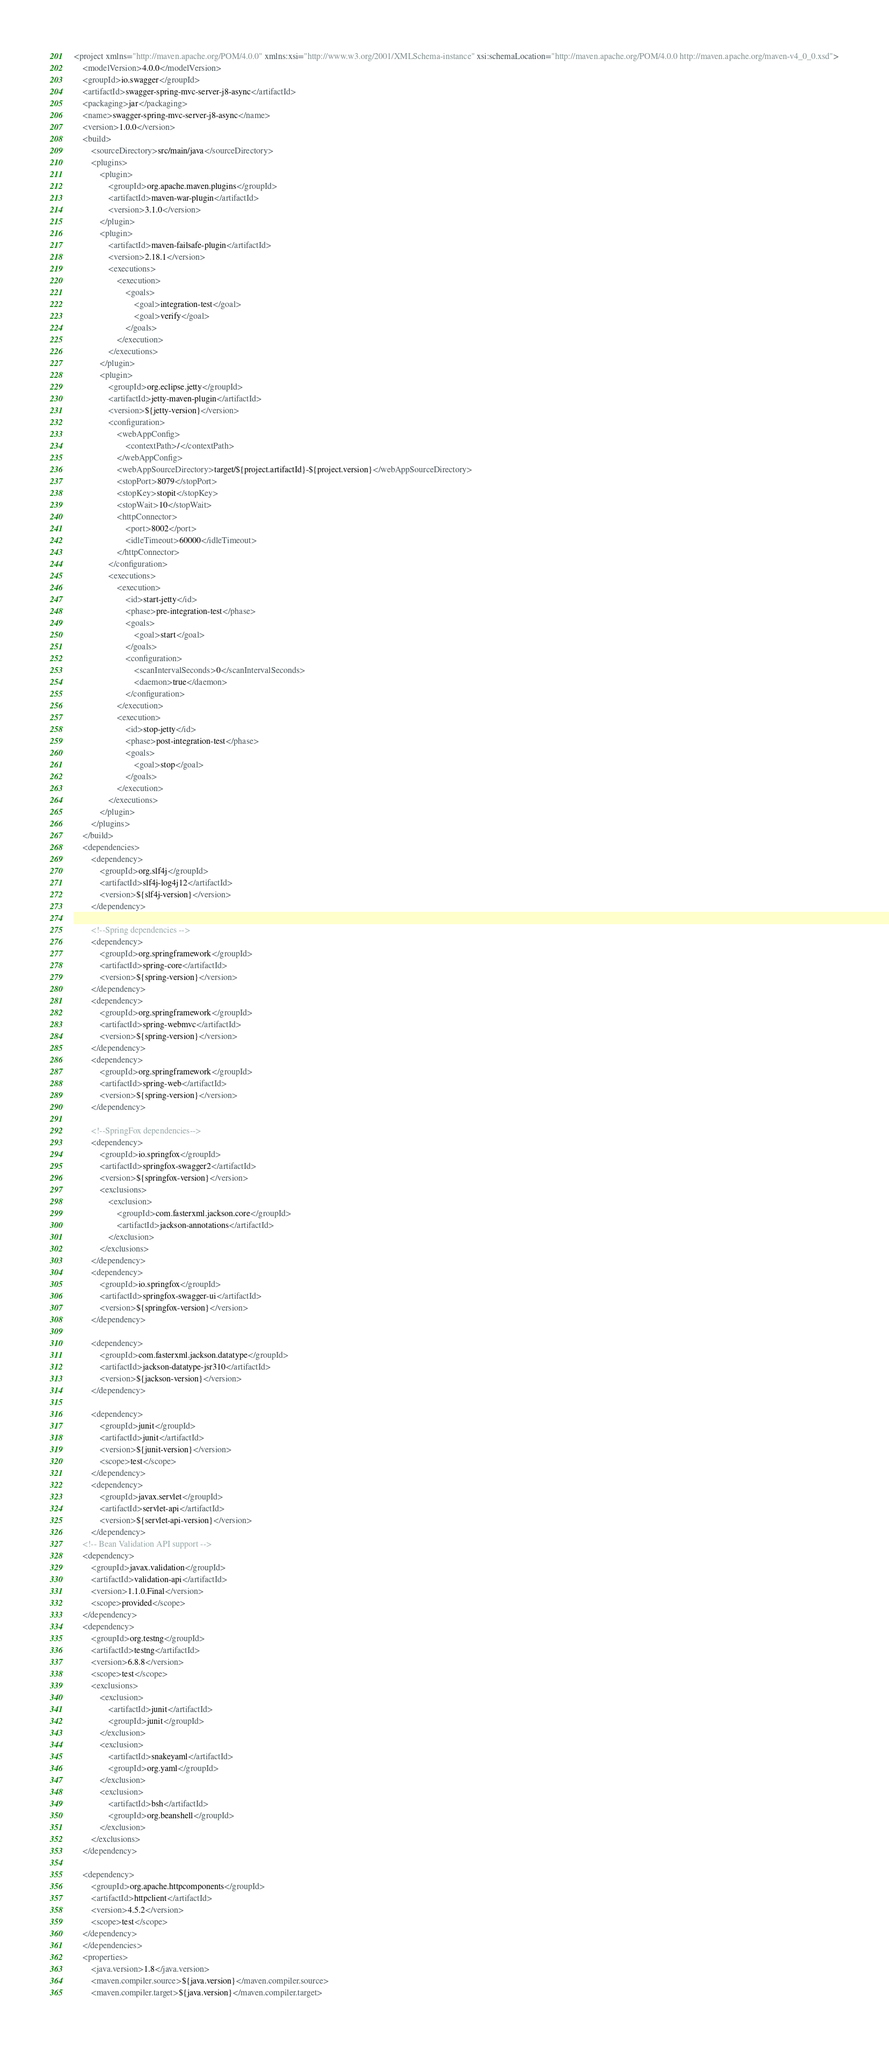<code> <loc_0><loc_0><loc_500><loc_500><_XML_><project xmlns="http://maven.apache.org/POM/4.0.0" xmlns:xsi="http://www.w3.org/2001/XMLSchema-instance" xsi:schemaLocation="http://maven.apache.org/POM/4.0.0 http://maven.apache.org/maven-v4_0_0.xsd">
    <modelVersion>4.0.0</modelVersion>
    <groupId>io.swagger</groupId>
    <artifactId>swagger-spring-mvc-server-j8-async</artifactId>
    <packaging>jar</packaging>
    <name>swagger-spring-mvc-server-j8-async</name>
    <version>1.0.0</version>
    <build>
        <sourceDirectory>src/main/java</sourceDirectory>
        <plugins>
            <plugin>
                <groupId>org.apache.maven.plugins</groupId>
                <artifactId>maven-war-plugin</artifactId>
                <version>3.1.0</version>
            </plugin>
            <plugin>
                <artifactId>maven-failsafe-plugin</artifactId>
                <version>2.18.1</version>
                <executions>
                    <execution>
                        <goals>
                            <goal>integration-test</goal>
                            <goal>verify</goal>
                        </goals>
                    </execution>
                </executions>
            </plugin>
            <plugin>
                <groupId>org.eclipse.jetty</groupId>
                <artifactId>jetty-maven-plugin</artifactId>
                <version>${jetty-version}</version>
                <configuration>
                    <webAppConfig>
                        <contextPath>/</contextPath>
                    </webAppConfig>
                    <webAppSourceDirectory>target/${project.artifactId}-${project.version}</webAppSourceDirectory>
                    <stopPort>8079</stopPort>
                    <stopKey>stopit</stopKey>
                    <stopWait>10</stopWait>
                    <httpConnector>
                        <port>8002</port>
                        <idleTimeout>60000</idleTimeout>
                    </httpConnector>
                </configuration>
                <executions>
                    <execution>
                        <id>start-jetty</id>
                        <phase>pre-integration-test</phase>
                        <goals>
                            <goal>start</goal>
                        </goals>
                        <configuration>
                            <scanIntervalSeconds>0</scanIntervalSeconds>
                            <daemon>true</daemon>
                        </configuration>
                    </execution>
                    <execution>
                        <id>stop-jetty</id>
                        <phase>post-integration-test</phase>
                        <goals>
                            <goal>stop</goal>
                        </goals>
                    </execution>
                </executions>
            </plugin>
        </plugins>
    </build>
    <dependencies>
        <dependency>
            <groupId>org.slf4j</groupId>
            <artifactId>slf4j-log4j12</artifactId>
            <version>${slf4j-version}</version>
        </dependency>

        <!--Spring dependencies -->
        <dependency>
            <groupId>org.springframework</groupId>
            <artifactId>spring-core</artifactId>
            <version>${spring-version}</version>
        </dependency>
        <dependency>
            <groupId>org.springframework</groupId>
            <artifactId>spring-webmvc</artifactId>
            <version>${spring-version}</version>
        </dependency>
        <dependency>
            <groupId>org.springframework</groupId>
            <artifactId>spring-web</artifactId>
            <version>${spring-version}</version>
        </dependency>

        <!--SpringFox dependencies-->
        <dependency>
            <groupId>io.springfox</groupId>
            <artifactId>springfox-swagger2</artifactId>
            <version>${springfox-version}</version>
            <exclusions>
                <exclusion>
                    <groupId>com.fasterxml.jackson.core</groupId>
                    <artifactId>jackson-annotations</artifactId>
                </exclusion>
            </exclusions>
        </dependency>
        <dependency>
            <groupId>io.springfox</groupId>
            <artifactId>springfox-swagger-ui</artifactId>
            <version>${springfox-version}</version>
        </dependency>

        <dependency>
            <groupId>com.fasterxml.jackson.datatype</groupId>
            <artifactId>jackson-datatype-jsr310</artifactId>
            <version>${jackson-version}</version>
        </dependency>

        <dependency>
            <groupId>junit</groupId>
            <artifactId>junit</artifactId>
            <version>${junit-version}</version>
            <scope>test</scope>
        </dependency>
        <dependency>
            <groupId>javax.servlet</groupId>
            <artifactId>servlet-api</artifactId>
            <version>${servlet-api-version}</version>
        </dependency>
    <!-- Bean Validation API support -->
    <dependency>
        <groupId>javax.validation</groupId>
        <artifactId>validation-api</artifactId>
        <version>1.1.0.Final</version>
        <scope>provided</scope>
    </dependency>
    <dependency>
        <groupId>org.testng</groupId>
        <artifactId>testng</artifactId>
        <version>6.8.8</version>
        <scope>test</scope>
        <exclusions>
            <exclusion>
                <artifactId>junit</artifactId>
                <groupId>junit</groupId>
            </exclusion>
            <exclusion>
                <artifactId>snakeyaml</artifactId>
                <groupId>org.yaml</groupId>
            </exclusion>
            <exclusion>
                <artifactId>bsh</artifactId>
                <groupId>org.beanshell</groupId>
            </exclusion>
        </exclusions>
    </dependency>

    <dependency>
        <groupId>org.apache.httpcomponents</groupId>
        <artifactId>httpclient</artifactId>
        <version>4.5.2</version>
        <scope>test</scope>
    </dependency>
    </dependencies>
    <properties>
        <java.version>1.8</java.version>
        <maven.compiler.source>${java.version}</maven.compiler.source>
        <maven.compiler.target>${java.version}</maven.compiler.target></code> 